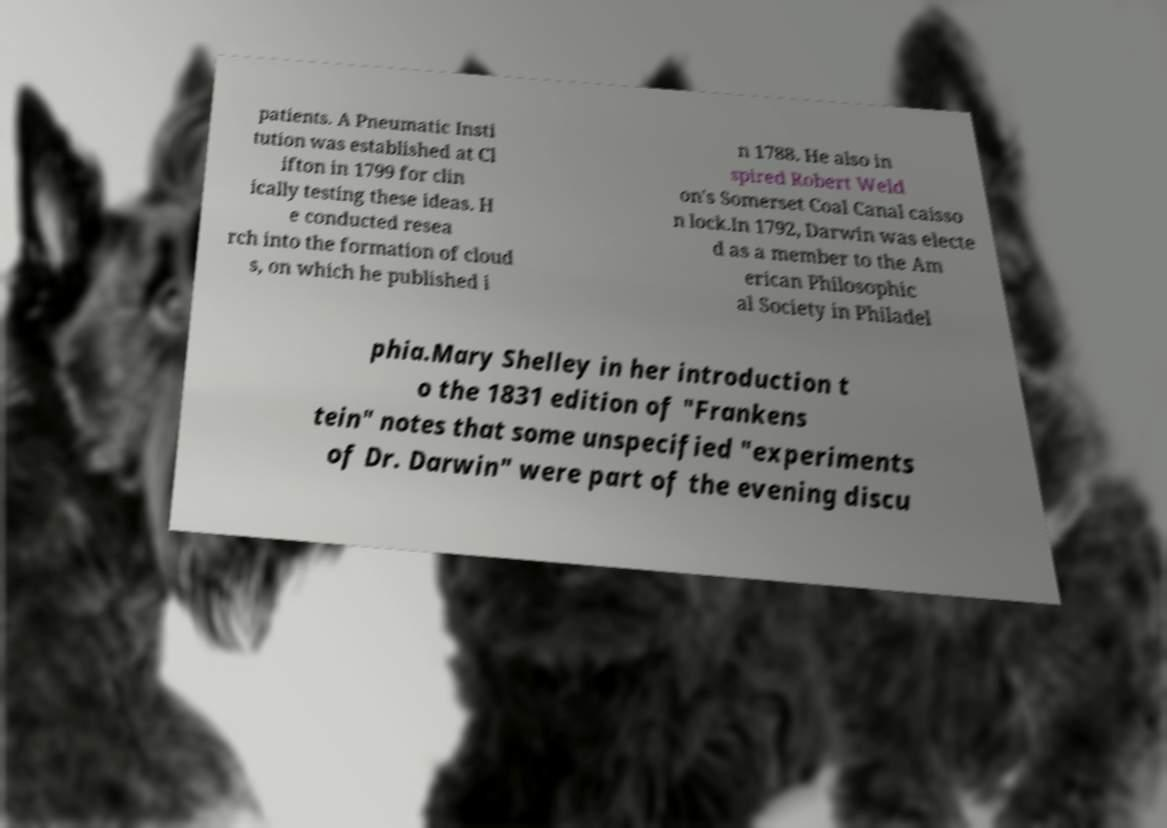For documentation purposes, I need the text within this image transcribed. Could you provide that? patients. A Pneumatic Insti tution was established at Cl ifton in 1799 for clin ically testing these ideas. H e conducted resea rch into the formation of cloud s, on which he published i n 1788. He also in spired Robert Weld on's Somerset Coal Canal caisso n lock.In 1792, Darwin was electe d as a member to the Am erican Philosophic al Society in Philadel phia.Mary Shelley in her introduction t o the 1831 edition of "Frankens tein" notes that some unspecified "experiments of Dr. Darwin" were part of the evening discu 